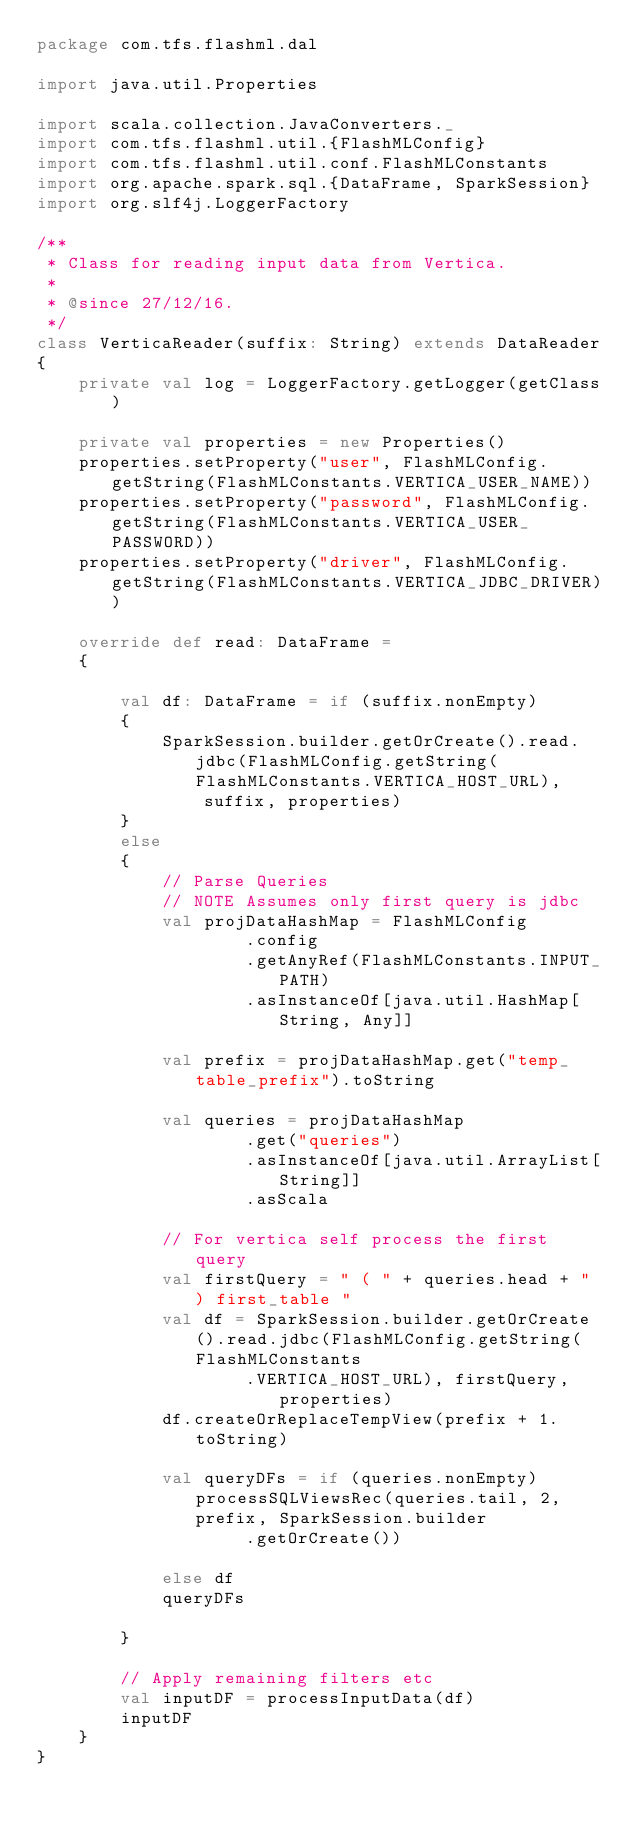Convert code to text. <code><loc_0><loc_0><loc_500><loc_500><_Scala_>package com.tfs.flashml.dal

import java.util.Properties

import scala.collection.JavaConverters._
import com.tfs.flashml.util.{FlashMLConfig}
import com.tfs.flashml.util.conf.FlashMLConstants
import org.apache.spark.sql.{DataFrame, SparkSession}
import org.slf4j.LoggerFactory

/**
 * Class for reading input data from Vertica.
 *
 * @since 27/12/16.
 */
class VerticaReader(suffix: String) extends DataReader
{
    private val log = LoggerFactory.getLogger(getClass)

    private val properties = new Properties()
    properties.setProperty("user", FlashMLConfig.getString(FlashMLConstants.VERTICA_USER_NAME))
    properties.setProperty("password", FlashMLConfig.getString(FlashMLConstants.VERTICA_USER_PASSWORD))
    properties.setProperty("driver", FlashMLConfig.getString(FlashMLConstants.VERTICA_JDBC_DRIVER))

    override def read: DataFrame =
    {

        val df: DataFrame = if (suffix.nonEmpty)
        {
            SparkSession.builder.getOrCreate().read.jdbc(FlashMLConfig.getString(FlashMLConstants.VERTICA_HOST_URL),
                suffix, properties)
        }
        else
        {
            // Parse Queries
            // NOTE Assumes only first query is jdbc
            val projDataHashMap = FlashMLConfig
                    .config
                    .getAnyRef(FlashMLConstants.INPUT_PATH)
                    .asInstanceOf[java.util.HashMap[String, Any]]

            val prefix = projDataHashMap.get("temp_table_prefix").toString

            val queries = projDataHashMap
                    .get("queries")
                    .asInstanceOf[java.util.ArrayList[String]]
                    .asScala

            // For vertica self process the first query
            val firstQuery = " ( " + queries.head + " ) first_table "
            val df = SparkSession.builder.getOrCreate().read.jdbc(FlashMLConfig.getString(FlashMLConstants
                    .VERTICA_HOST_URL), firstQuery, properties)
            df.createOrReplaceTempView(prefix + 1.toString)

            val queryDFs = if (queries.nonEmpty) processSQLViewsRec(queries.tail, 2, prefix, SparkSession.builder
                    .getOrCreate())

            else df
            queryDFs

        }

        // Apply remaining filters etc
        val inputDF = processInputData(df)
        inputDF
    }
}</code> 